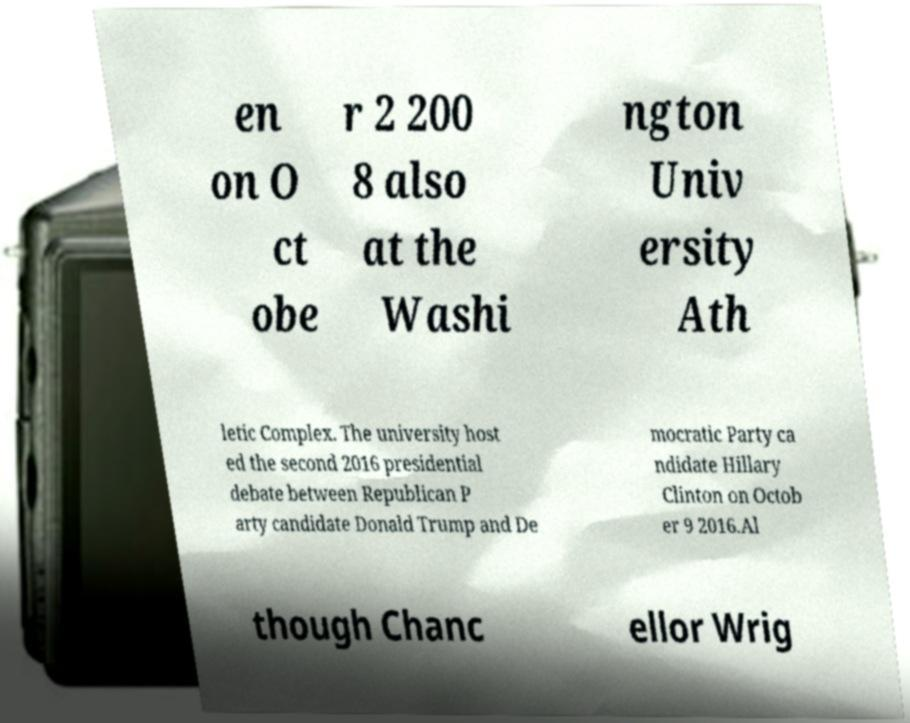Can you read and provide the text displayed in the image?This photo seems to have some interesting text. Can you extract and type it out for me? en on O ct obe r 2 200 8 also at the Washi ngton Univ ersity Ath letic Complex. The university host ed the second 2016 presidential debate between Republican P arty candidate Donald Trump and De mocratic Party ca ndidate Hillary Clinton on Octob er 9 2016.Al though Chanc ellor Wrig 